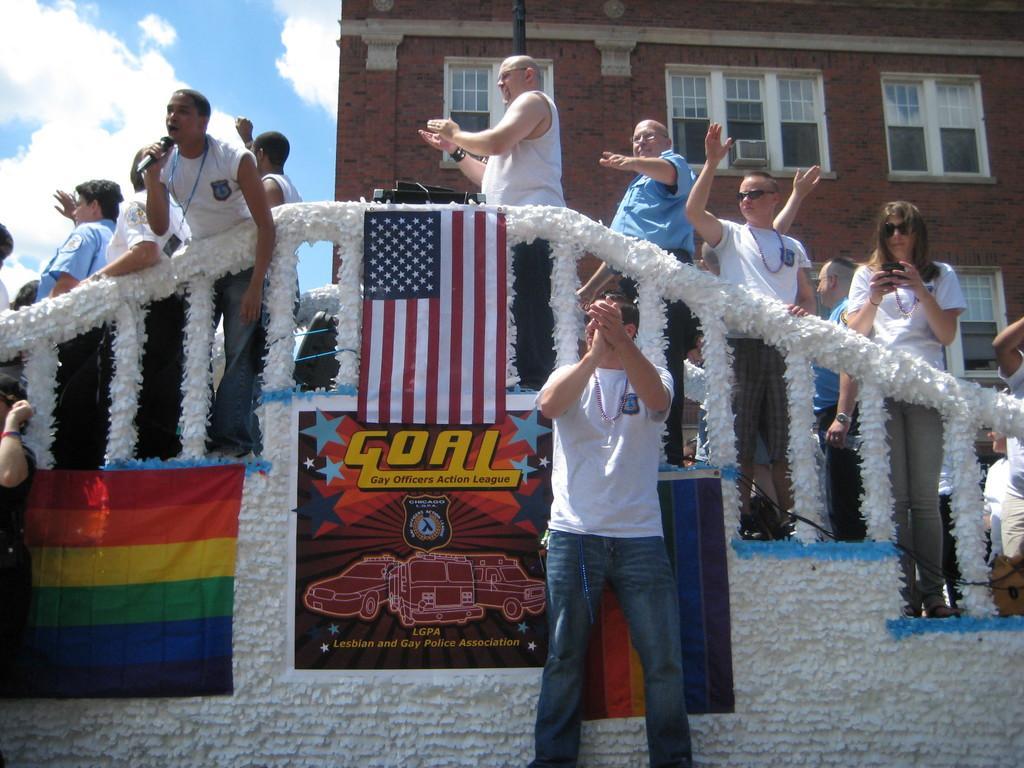Please provide a concise description of this image. In this image we can see people, railing, flags, poster, wall, windows, and a building. In the background there is sky with clouds. 